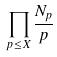<formula> <loc_0><loc_0><loc_500><loc_500>\prod _ { p \leq X } \frac { N _ { p } } { p }</formula> 